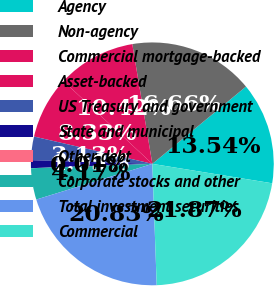Convert chart to OTSL. <chart><loc_0><loc_0><loc_500><loc_500><pie_chart><fcel>Agency<fcel>Non-agency<fcel>Commercial mortgage-backed<fcel>Asset-backed<fcel>US Treasury and government<fcel>State and municipal<fcel>Other debt<fcel>Corporate stocks and other<fcel>Total investment securities<fcel>Commercial<nl><fcel>13.54%<fcel>16.66%<fcel>10.42%<fcel>8.33%<fcel>3.13%<fcel>1.05%<fcel>0.01%<fcel>4.17%<fcel>20.83%<fcel>21.87%<nl></chart> 